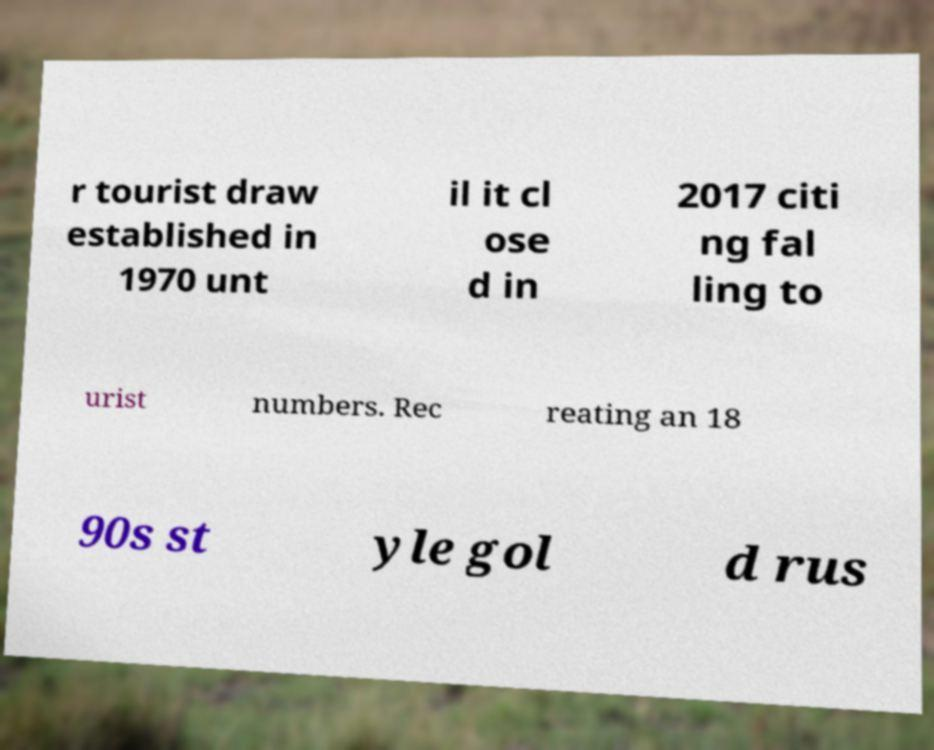What messages or text are displayed in this image? I need them in a readable, typed format. r tourist draw established in 1970 unt il it cl ose d in 2017 citi ng fal ling to urist numbers. Rec reating an 18 90s st yle gol d rus 